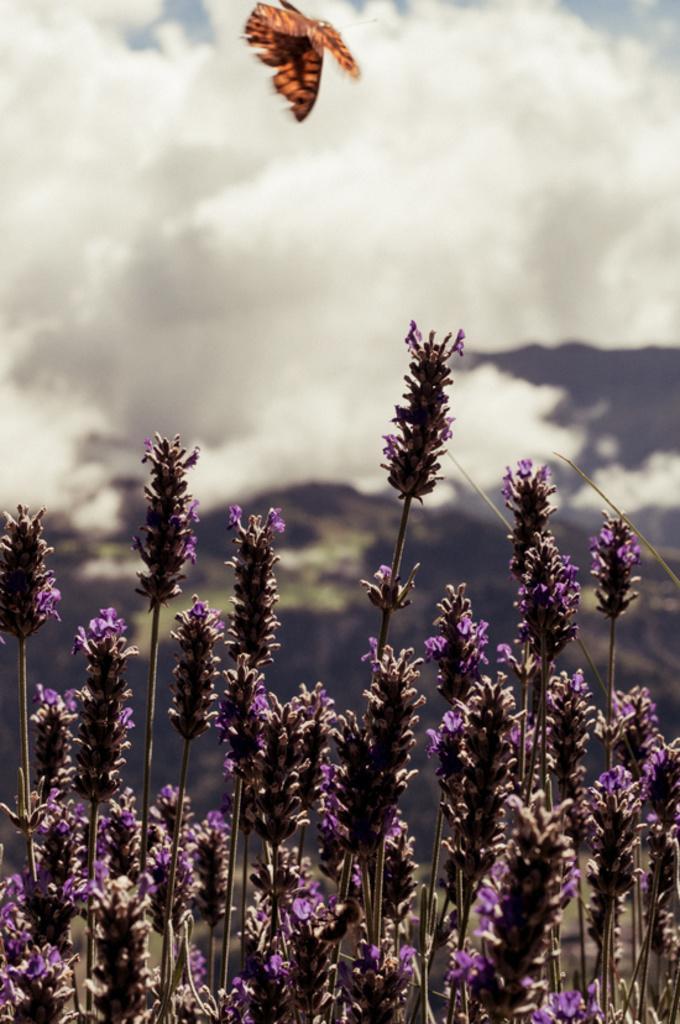Could you give a brief overview of what you see in this image? In this image there are few plants having flowers. Top of the image there is a butterfly flying in the air. Background there is sky, having clouds. 